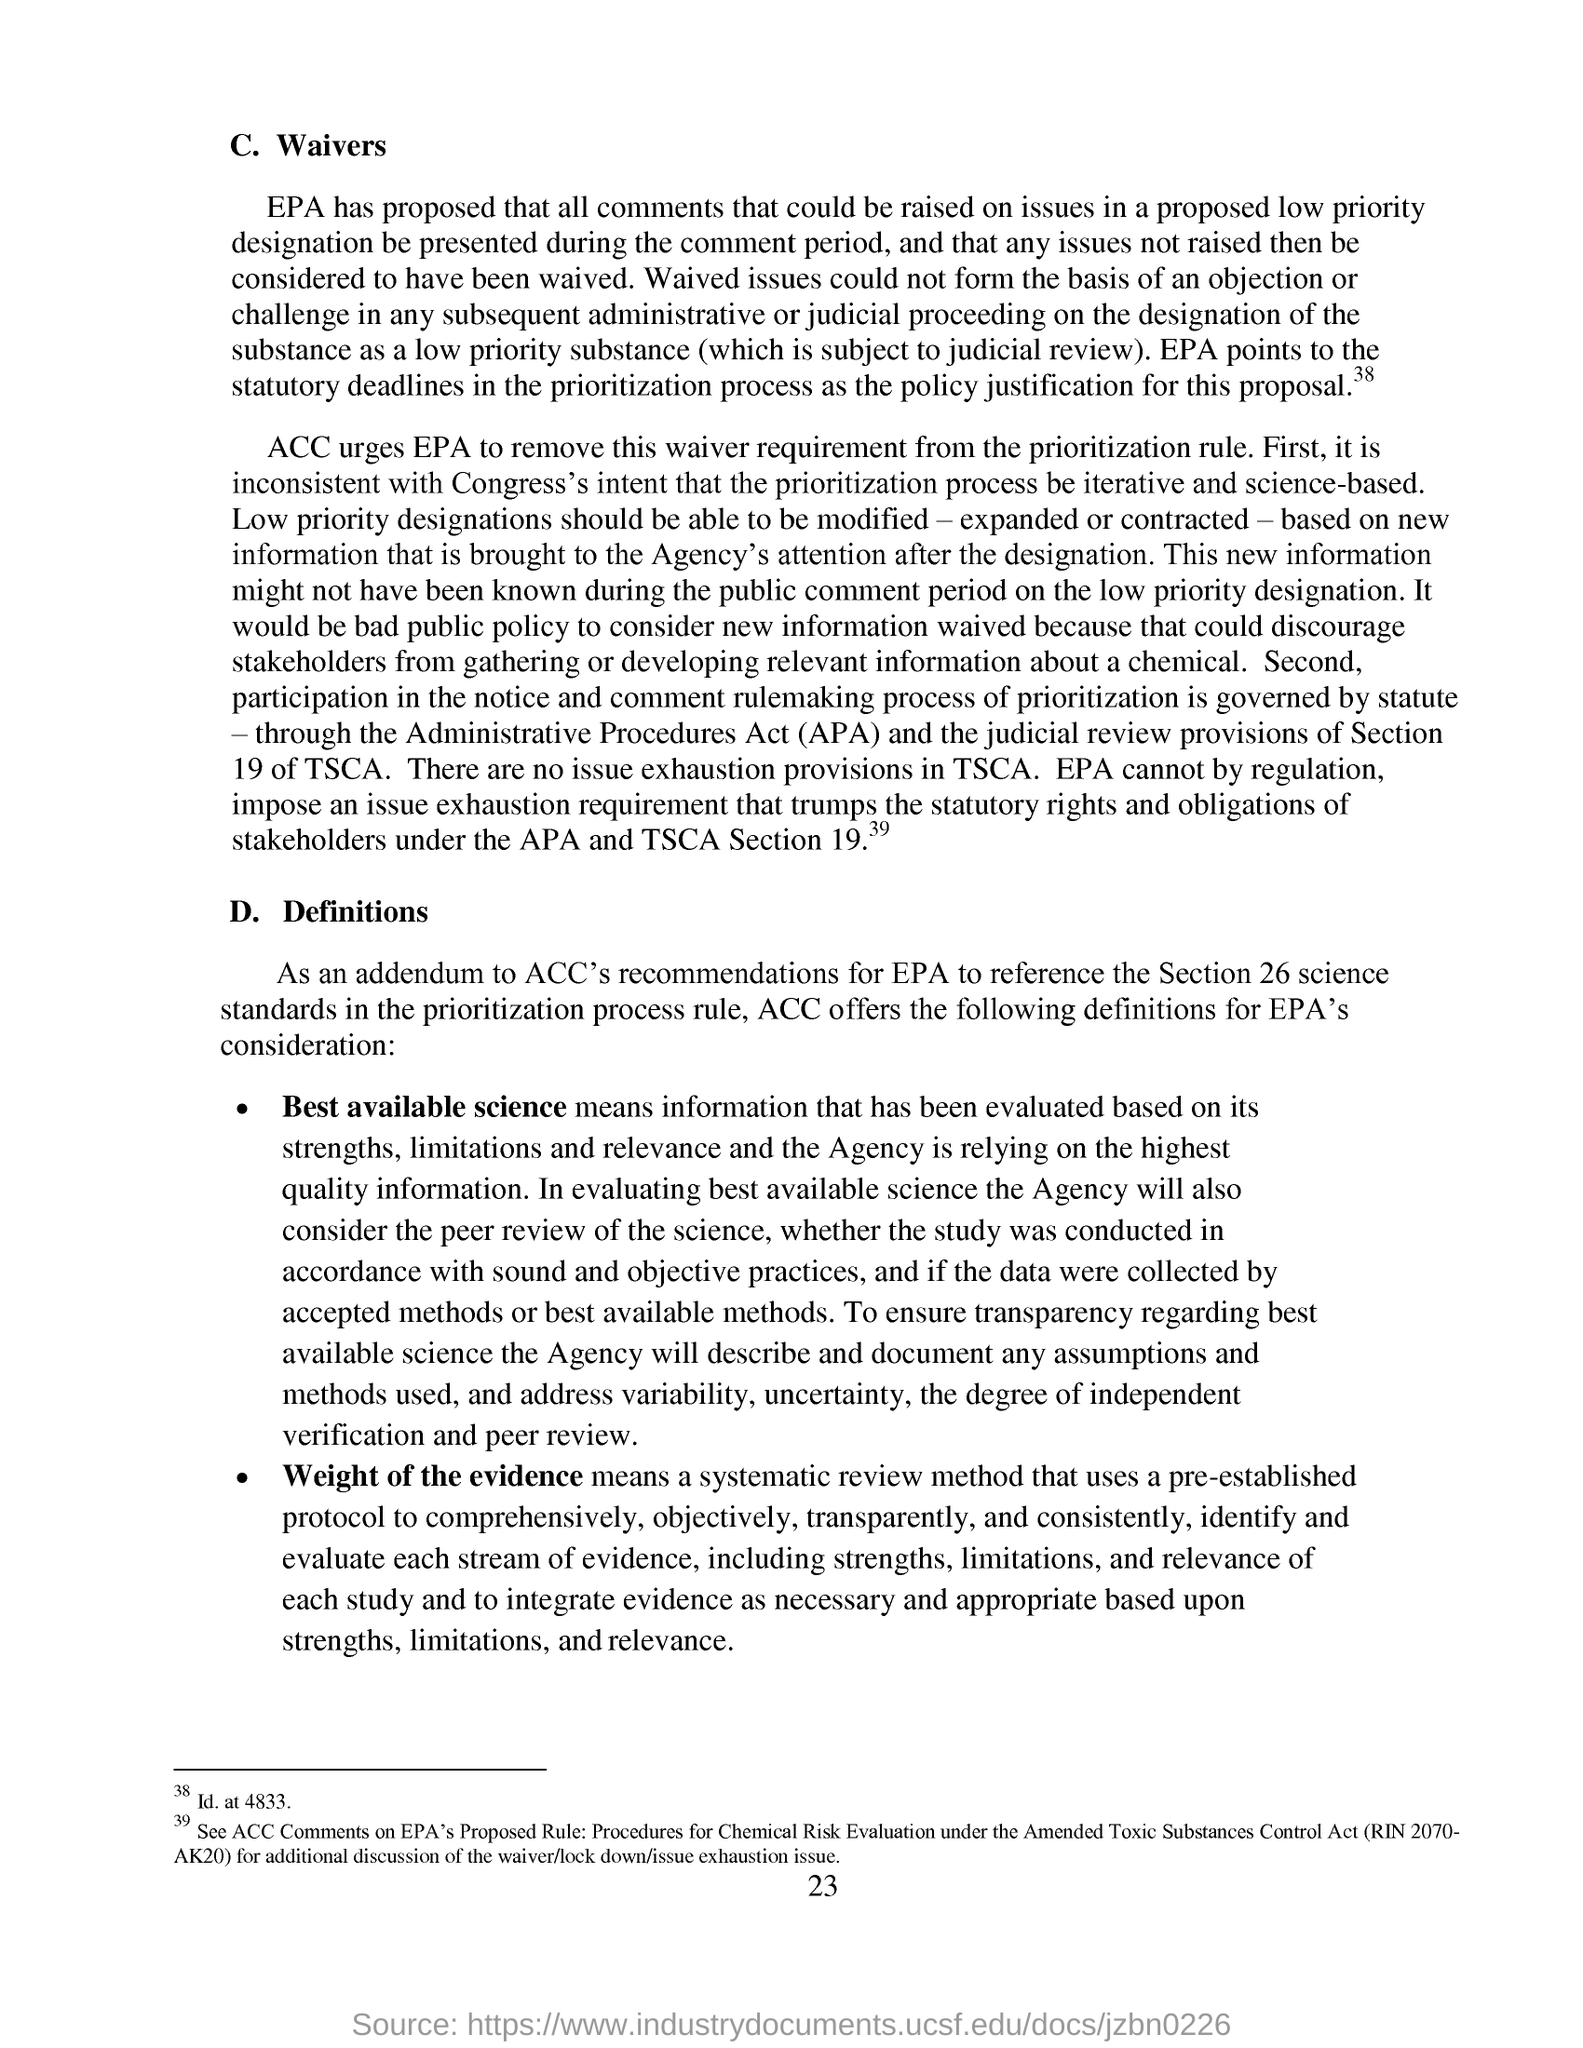What does APA stands for?
Ensure brevity in your answer.  Administrative procedures act. Which urges epa to remove this wavier requirement from the prioritisation rule ?
Ensure brevity in your answer.  ACC. What should be able to be modified-expanded or contracted ?
Your answer should be very brief. Low priority designations. 